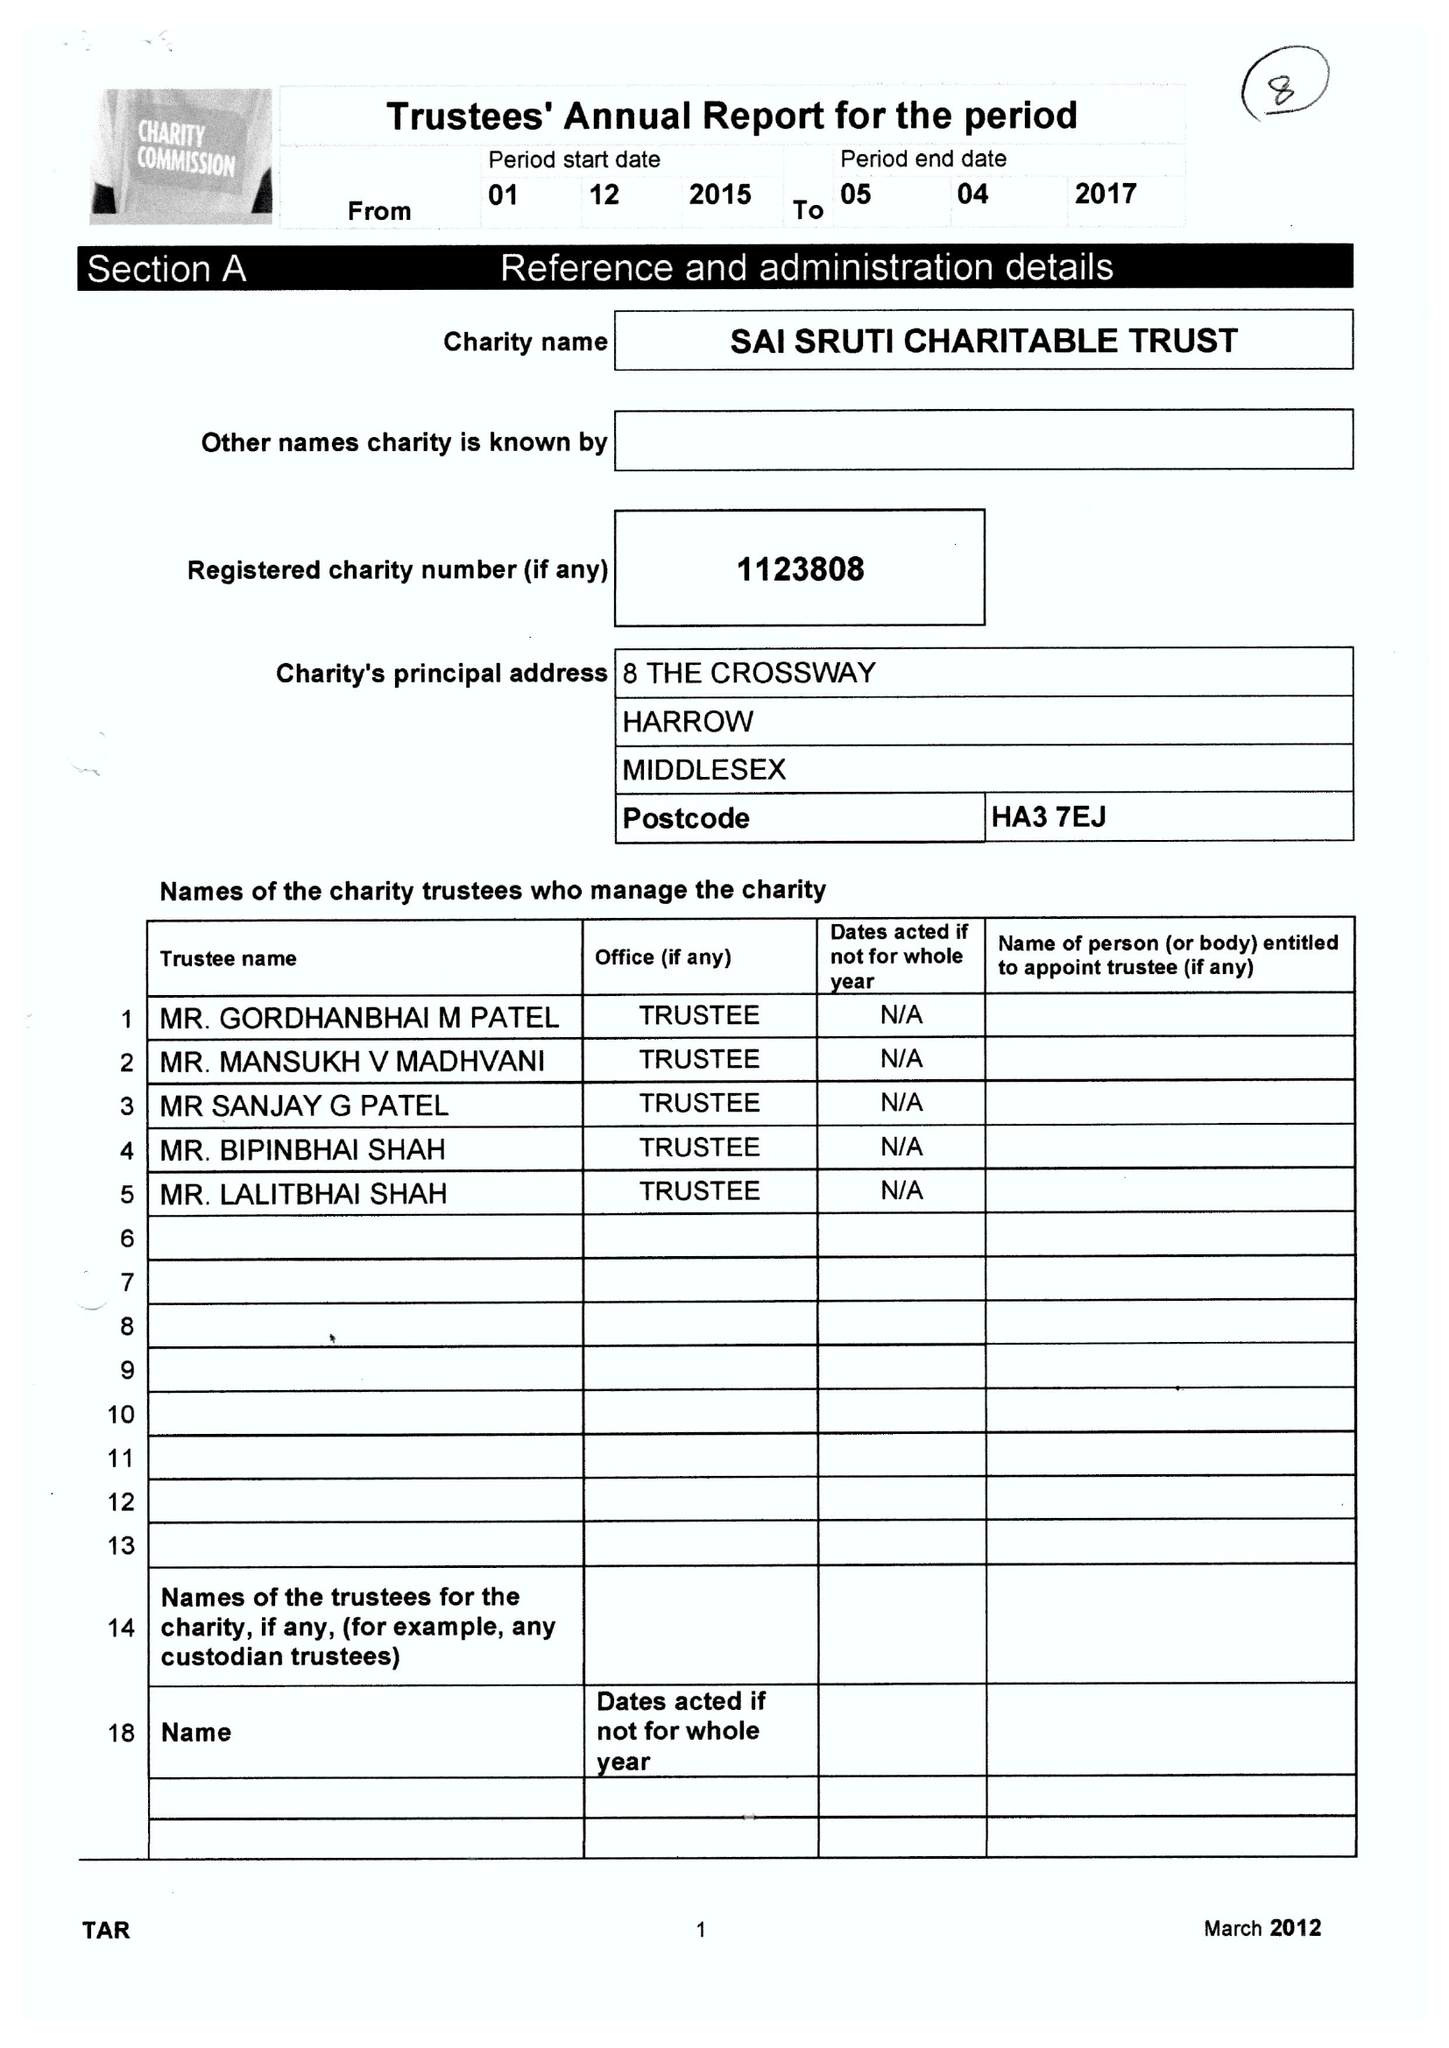What is the value for the charity_name?
Answer the question using a single word or phrase. Sai Sruti Charitable Trust 